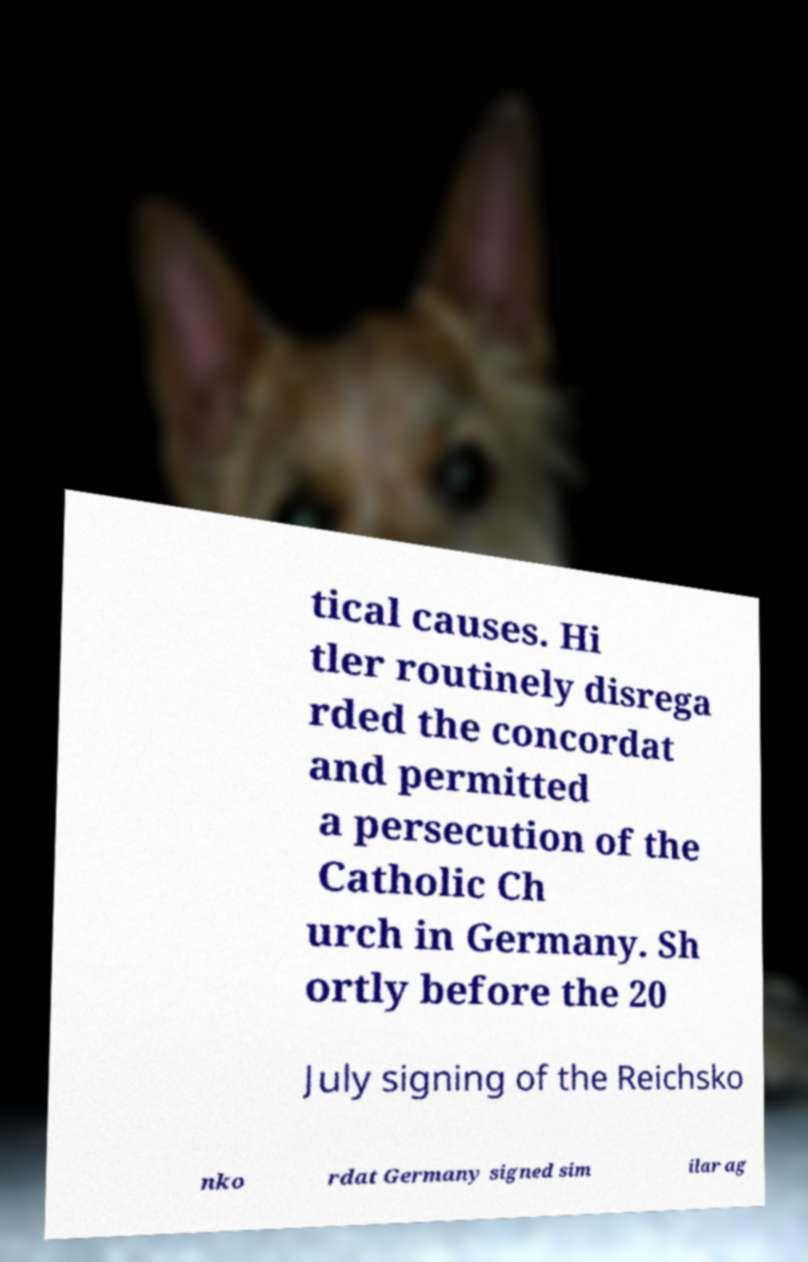Can you accurately transcribe the text from the provided image for me? tical causes. Hi tler routinely disrega rded the concordat and permitted a persecution of the Catholic Ch urch in Germany. Sh ortly before the 20 July signing of the Reichsko nko rdat Germany signed sim ilar ag 